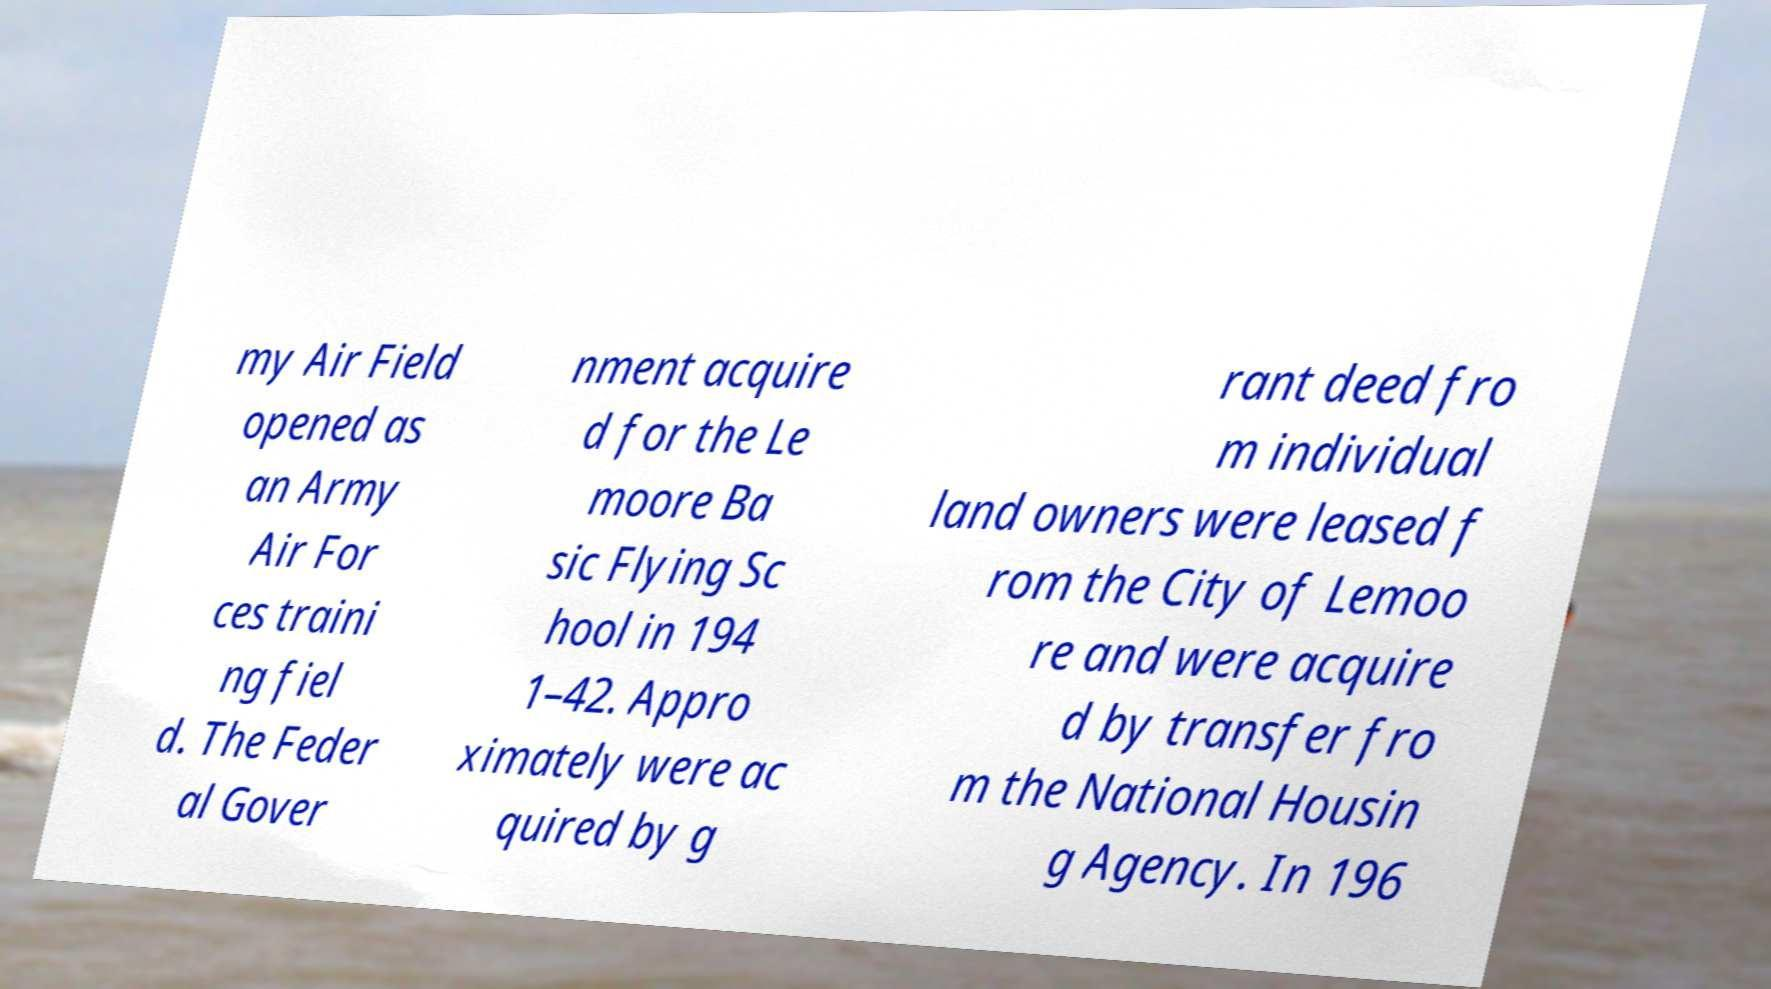Could you assist in decoding the text presented in this image and type it out clearly? my Air Field opened as an Army Air For ces traini ng fiel d. The Feder al Gover nment acquire d for the Le moore Ba sic Flying Sc hool in 194 1–42. Appro ximately were ac quired by g rant deed fro m individual land owners were leased f rom the City of Lemoo re and were acquire d by transfer fro m the National Housin g Agency. In 196 